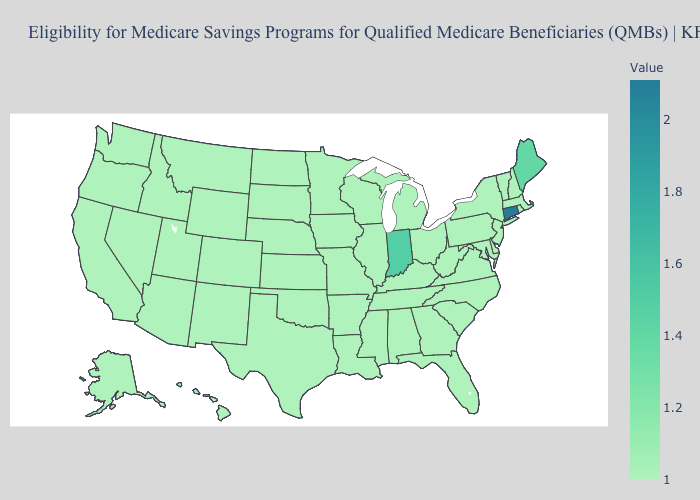Is the legend a continuous bar?
Give a very brief answer. Yes. Which states have the lowest value in the USA?
Write a very short answer. Alabama, Alaska, Arizona, Arkansas, California, Colorado, Delaware, Florida, Georgia, Hawaii, Idaho, Illinois, Iowa, Kansas, Kentucky, Louisiana, Maryland, Massachusetts, Michigan, Minnesota, Mississippi, Missouri, Montana, Nebraska, Nevada, New Hampshire, New Jersey, New Mexico, New York, North Carolina, North Dakota, Ohio, Oklahoma, Oregon, Pennsylvania, Rhode Island, South Carolina, South Dakota, Tennessee, Texas, Utah, Vermont, Virginia, Washington, West Virginia, Wisconsin, Wyoming. Which states have the highest value in the USA?
Write a very short answer. Connecticut. Does Indiana have the highest value in the MidWest?
Keep it brief. Yes. 